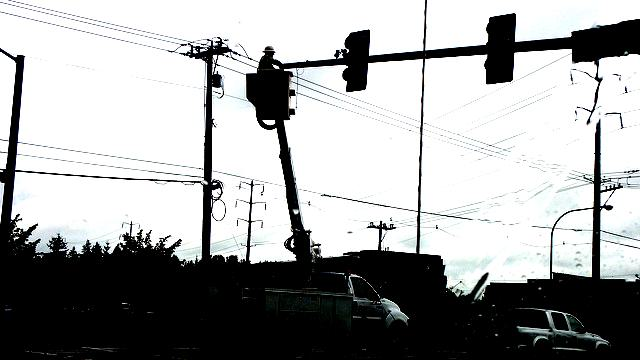Can you identify the likely setting or environment shown in the image? Based on the silhouettes and shapes present in the image, it seems to depict an urban street scene. The traffic light, utility poles, and overhead lines suggest a city or town location, possibly at an intersection. The silhouette of a vehicle implies the presence of a roadway, and the buildings in the background further reinforce the urban environment. 